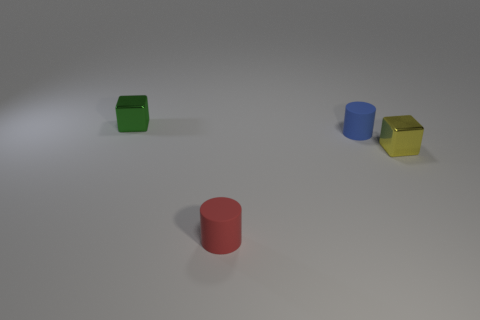Subtract all blue cylinders. How many cylinders are left? 1 Subtract all purple cubes. How many red cylinders are left? 1 Add 1 blue matte things. How many objects exist? 5 Subtract 0 green cylinders. How many objects are left? 4 Subtract 1 cylinders. How many cylinders are left? 1 Subtract all gray cylinders. Subtract all green blocks. How many cylinders are left? 2 Subtract all rubber things. Subtract all tiny rubber cylinders. How many objects are left? 0 Add 4 tiny blue objects. How many tiny blue objects are left? 5 Add 3 blocks. How many blocks exist? 5 